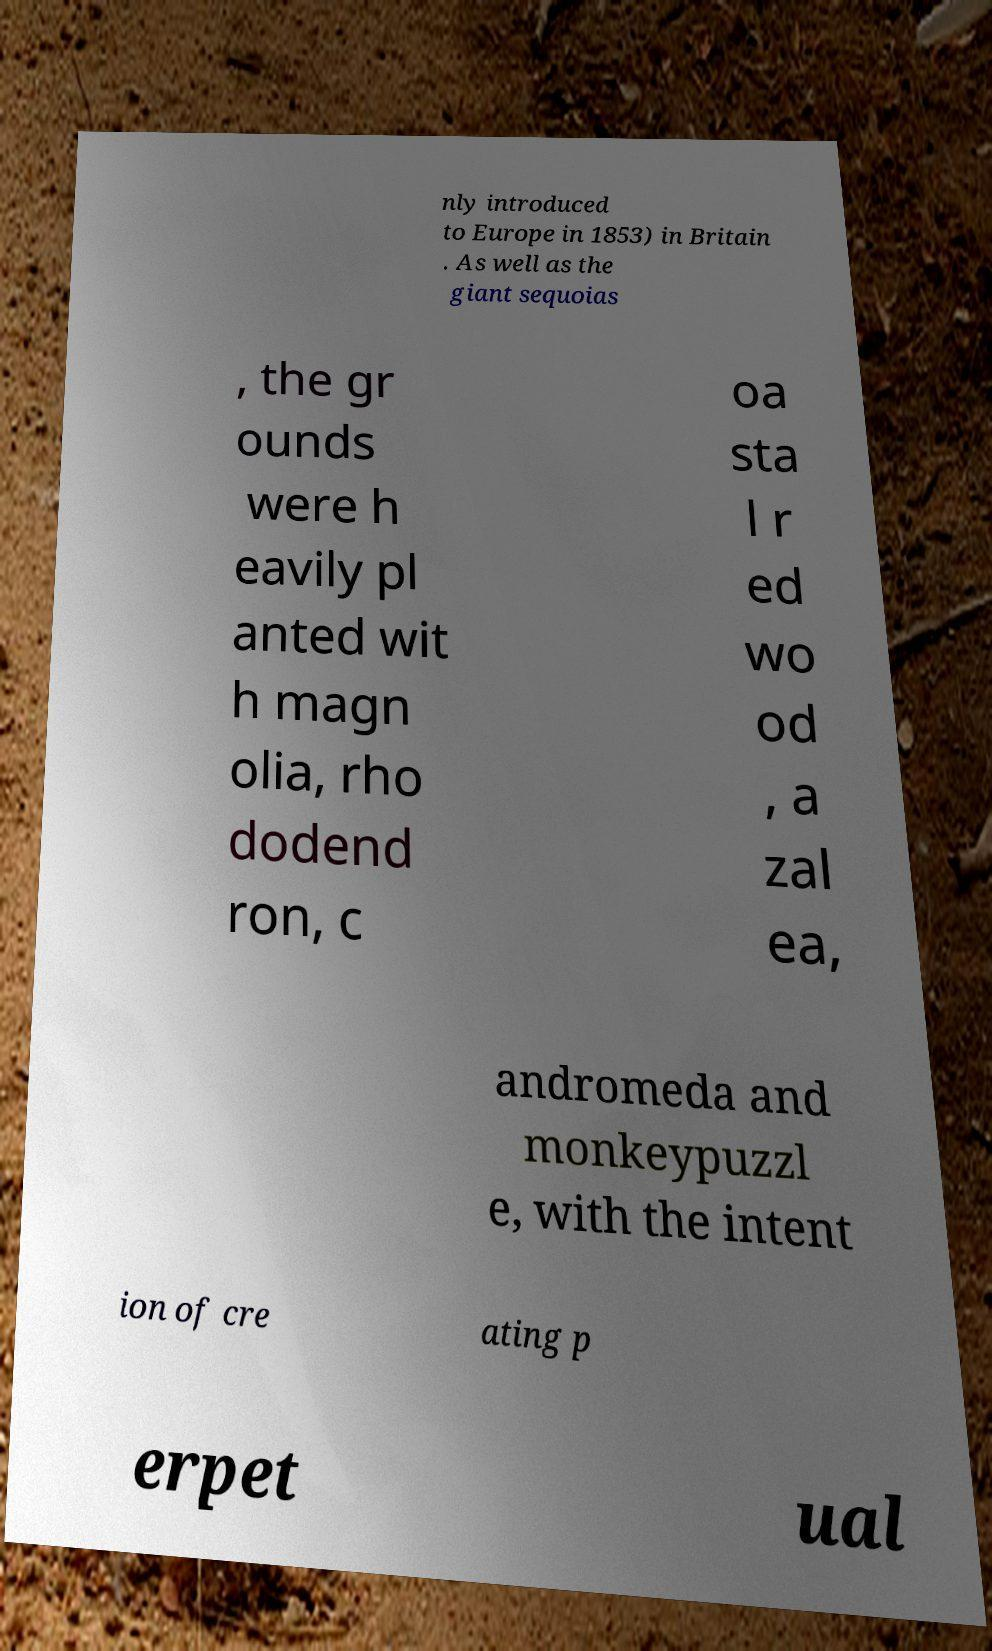For documentation purposes, I need the text within this image transcribed. Could you provide that? nly introduced to Europe in 1853) in Britain . As well as the giant sequoias , the gr ounds were h eavily pl anted wit h magn olia, rho dodend ron, c oa sta l r ed wo od , a zal ea, andromeda and monkeypuzzl e, with the intent ion of cre ating p erpet ual 